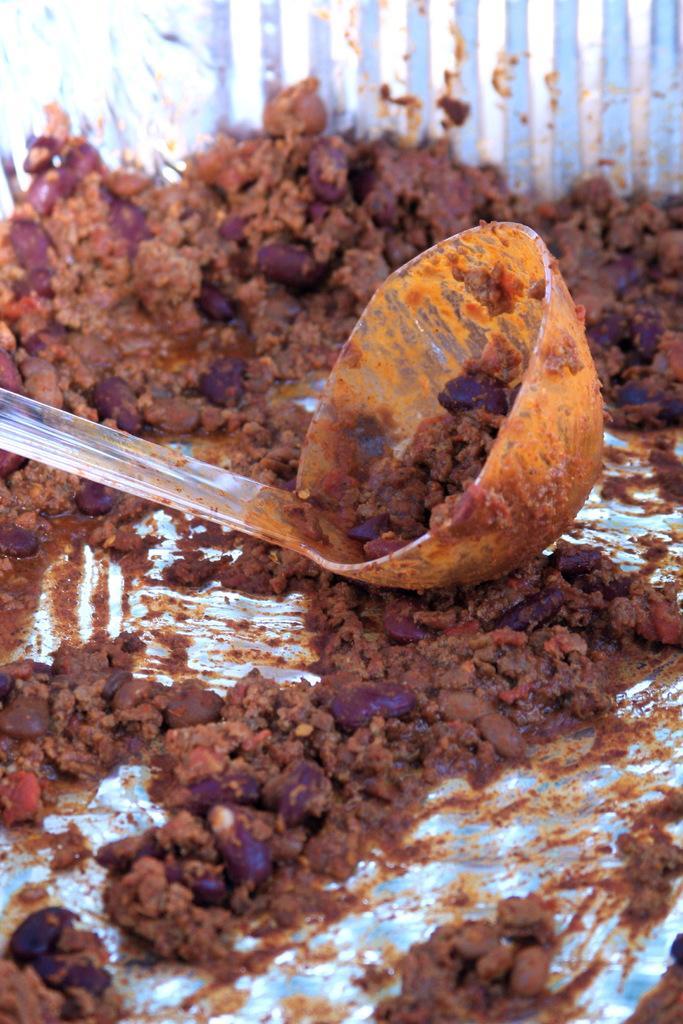In one or two sentences, can you explain what this image depicts? In the center of the image we can see one blue color object. In the blue color object, we can see one big spoon and some food items. In the background, we can see it is blurred. 